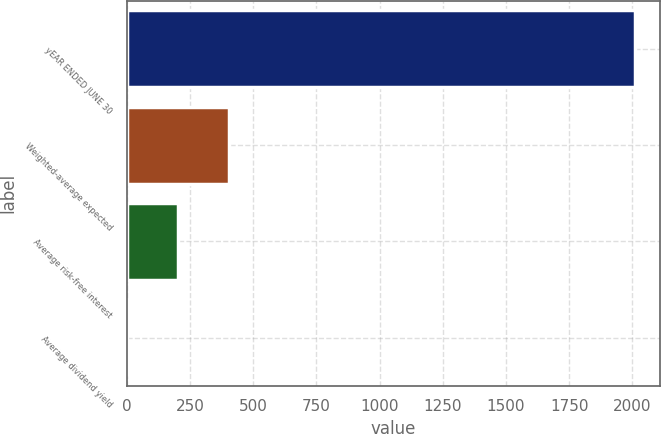Convert chart. <chart><loc_0><loc_0><loc_500><loc_500><bar_chart><fcel>yEAR ENDED JUNE 30<fcel>Weighted-average expected<fcel>Average risk-free interest<fcel>Average dividend yield<nl><fcel>2010<fcel>403.6<fcel>202.8<fcel>2<nl></chart> 